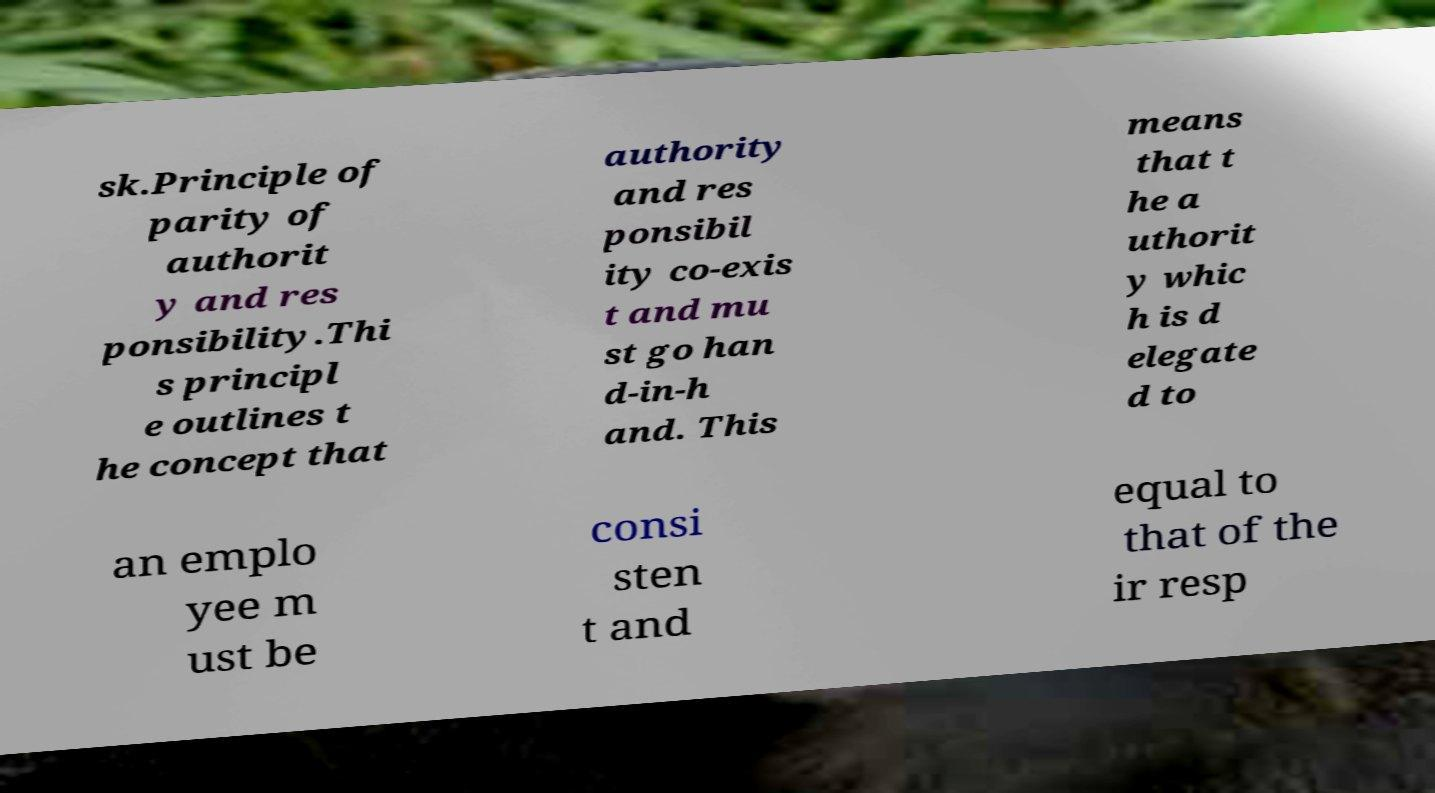Please identify and transcribe the text found in this image. sk.Principle of parity of authorit y and res ponsibility.Thi s principl e outlines t he concept that authority and res ponsibil ity co-exis t and mu st go han d-in-h and. This means that t he a uthorit y whic h is d elegate d to an emplo yee m ust be consi sten t and equal to that of the ir resp 